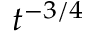Convert formula to latex. <formula><loc_0><loc_0><loc_500><loc_500>t ^ { - 3 / 4 }</formula> 